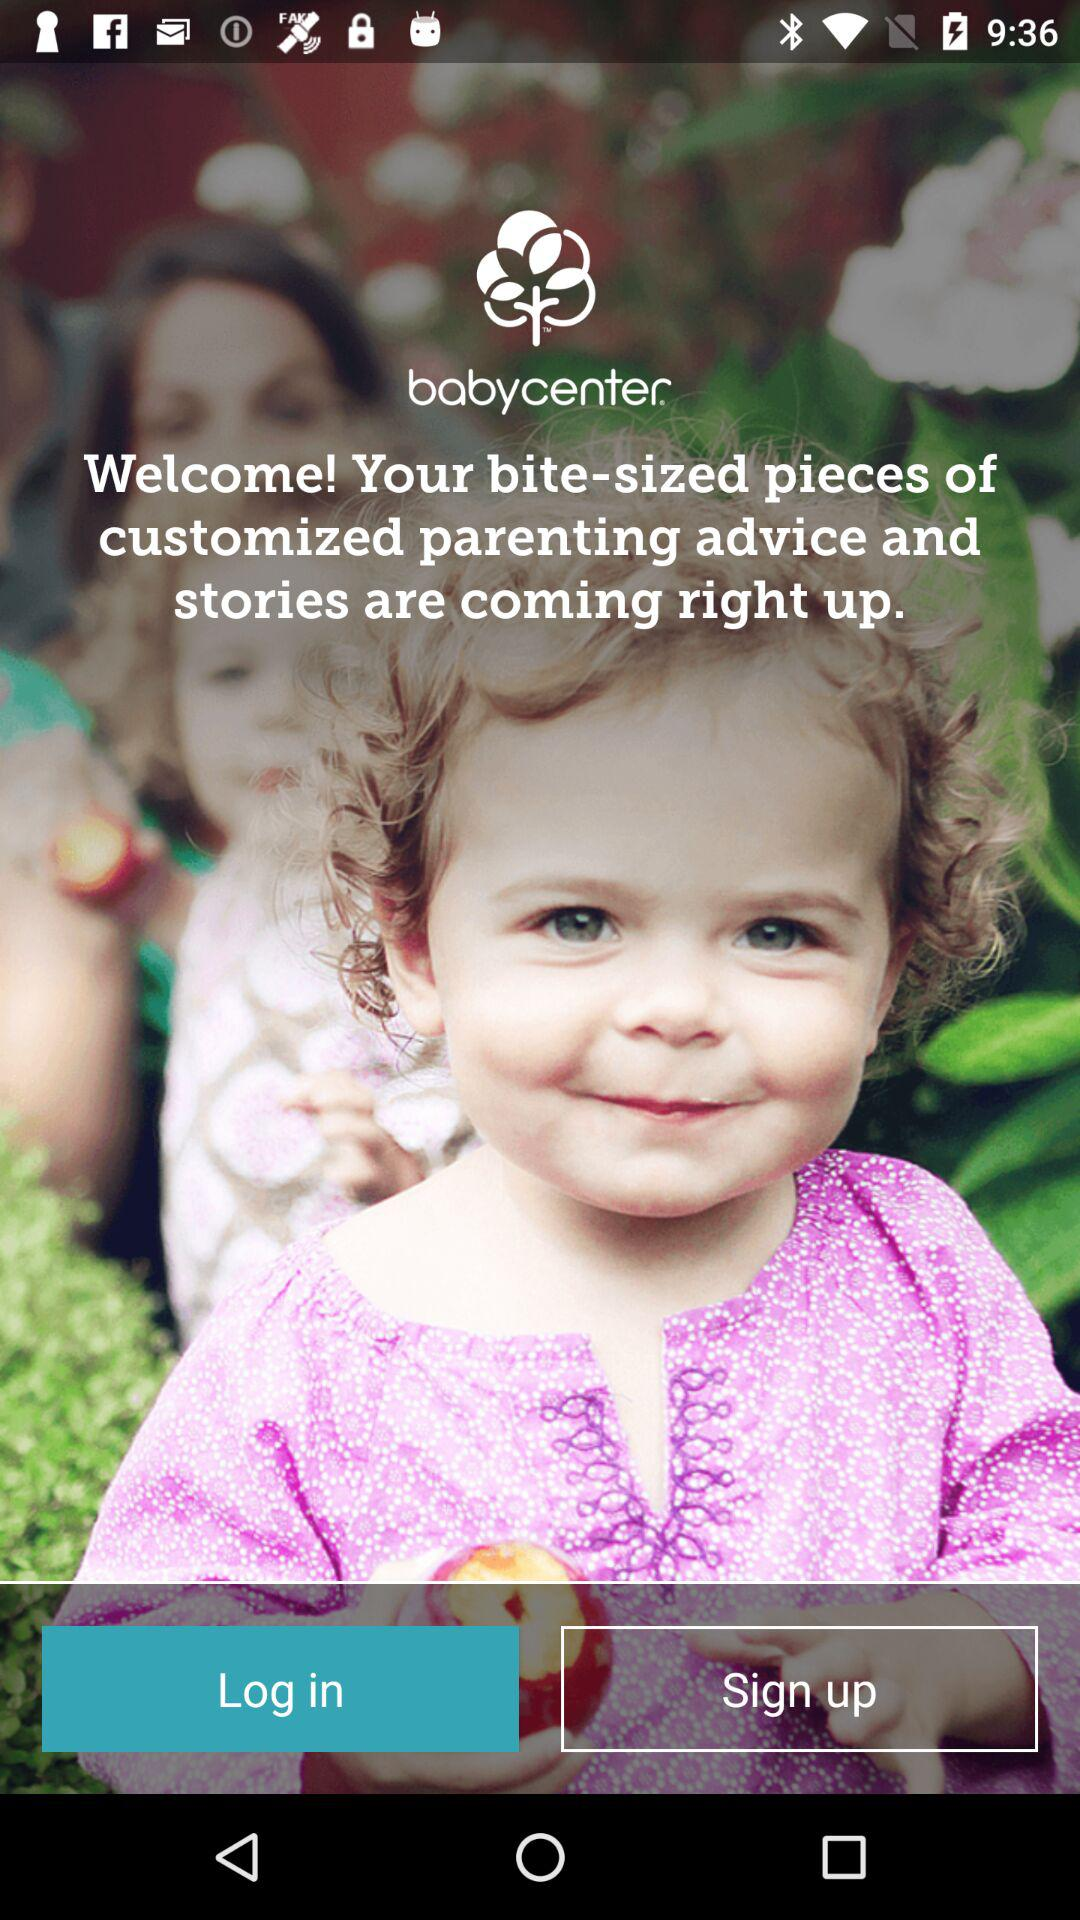What is the application name? The application name is "babycenter". 